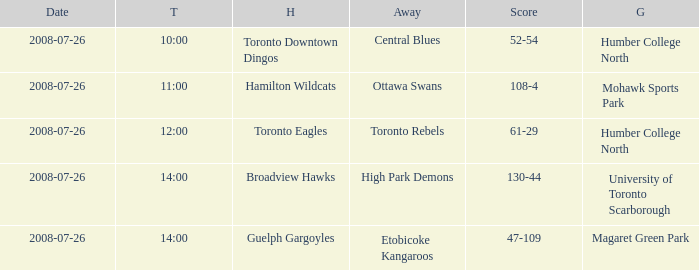The Away High Park Demons was which Ground? University of Toronto Scarborough. 